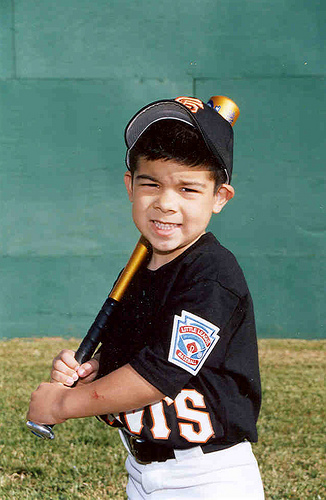Please transcribe the text information in this image. VTS 